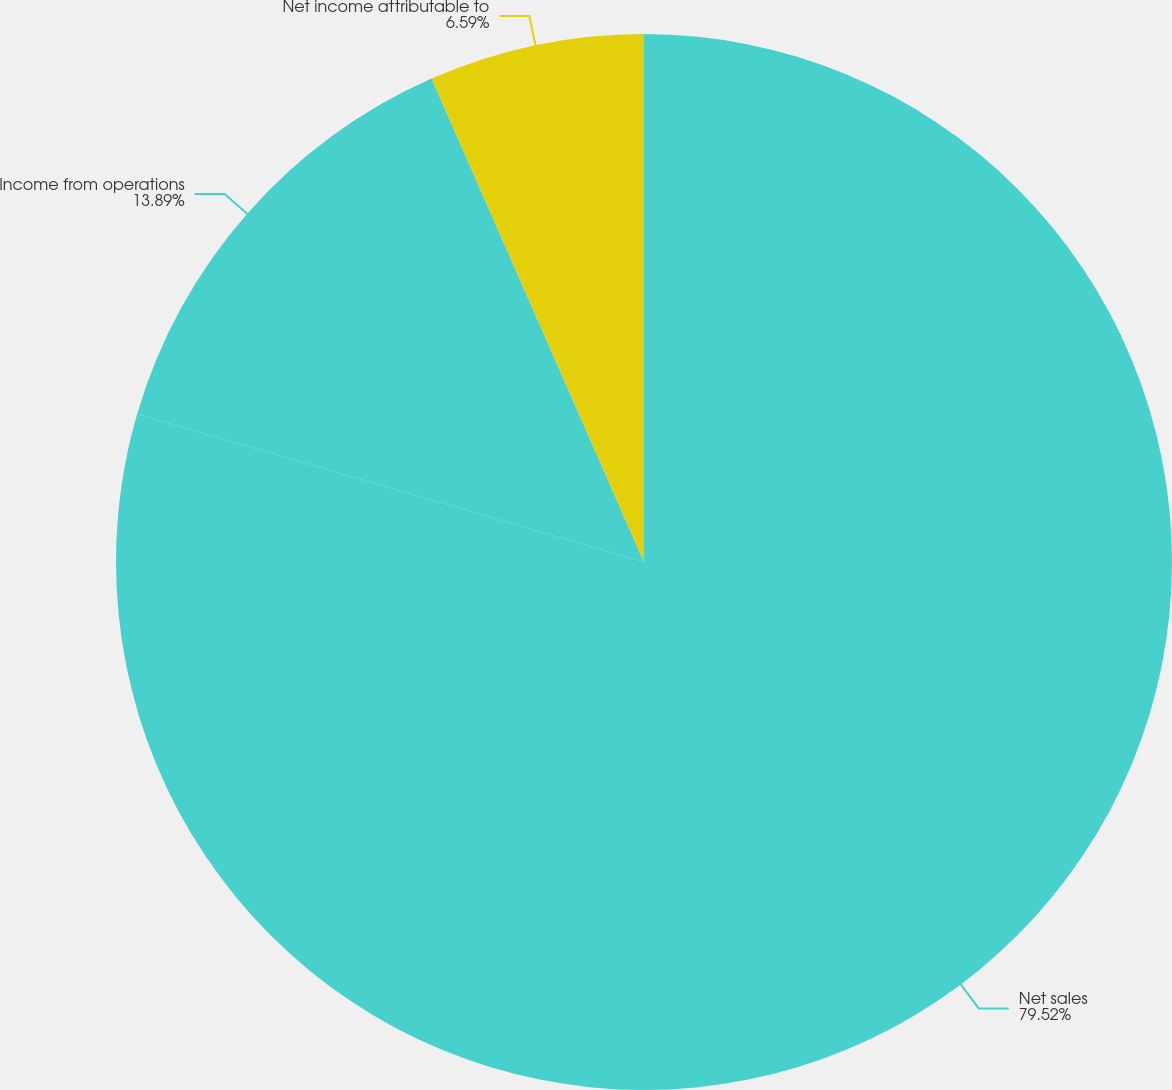Convert chart to OTSL. <chart><loc_0><loc_0><loc_500><loc_500><pie_chart><fcel>Net sales<fcel>Income from operations<fcel>Net income attributable to<nl><fcel>79.52%<fcel>13.89%<fcel>6.59%<nl></chart> 